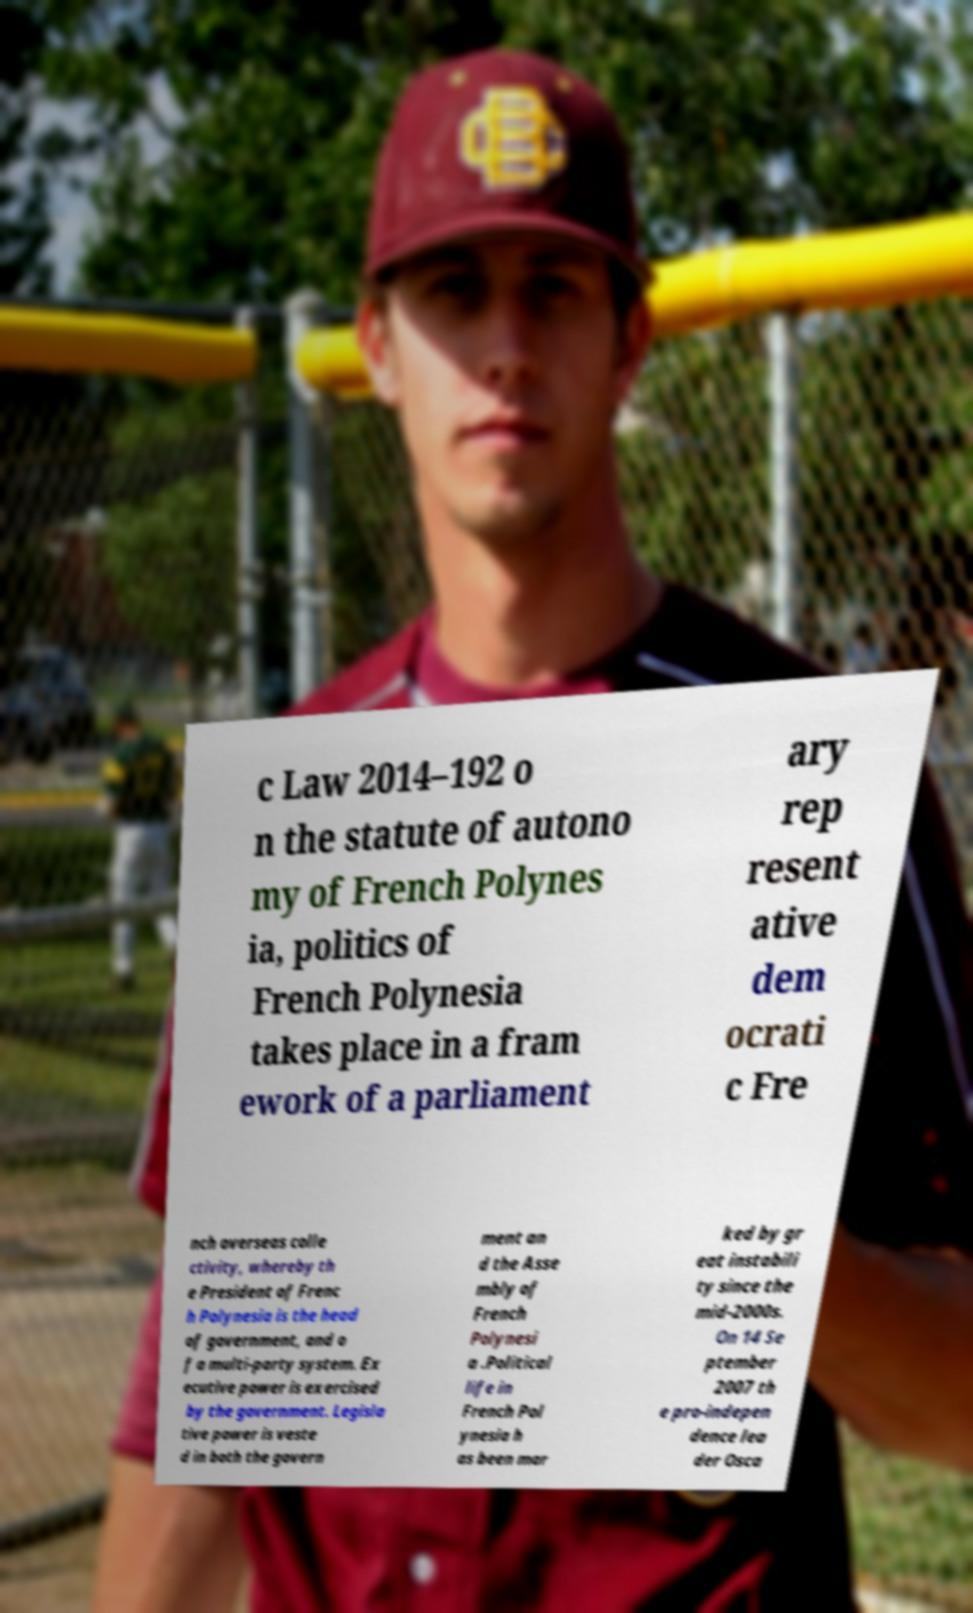Please read and relay the text visible in this image. What does it say? c Law 2014–192 o n the statute of autono my of French Polynes ia, politics of French Polynesia takes place in a fram ework of a parliament ary rep resent ative dem ocrati c Fre nch overseas colle ctivity, whereby th e President of Frenc h Polynesia is the head of government, and o f a multi-party system. Ex ecutive power is exercised by the government. Legisla tive power is veste d in both the govern ment an d the Asse mbly of French Polynesi a .Political life in French Pol ynesia h as been mar ked by gr eat instabili ty since the mid-2000s. On 14 Se ptember 2007 th e pro-indepen dence lea der Osca 